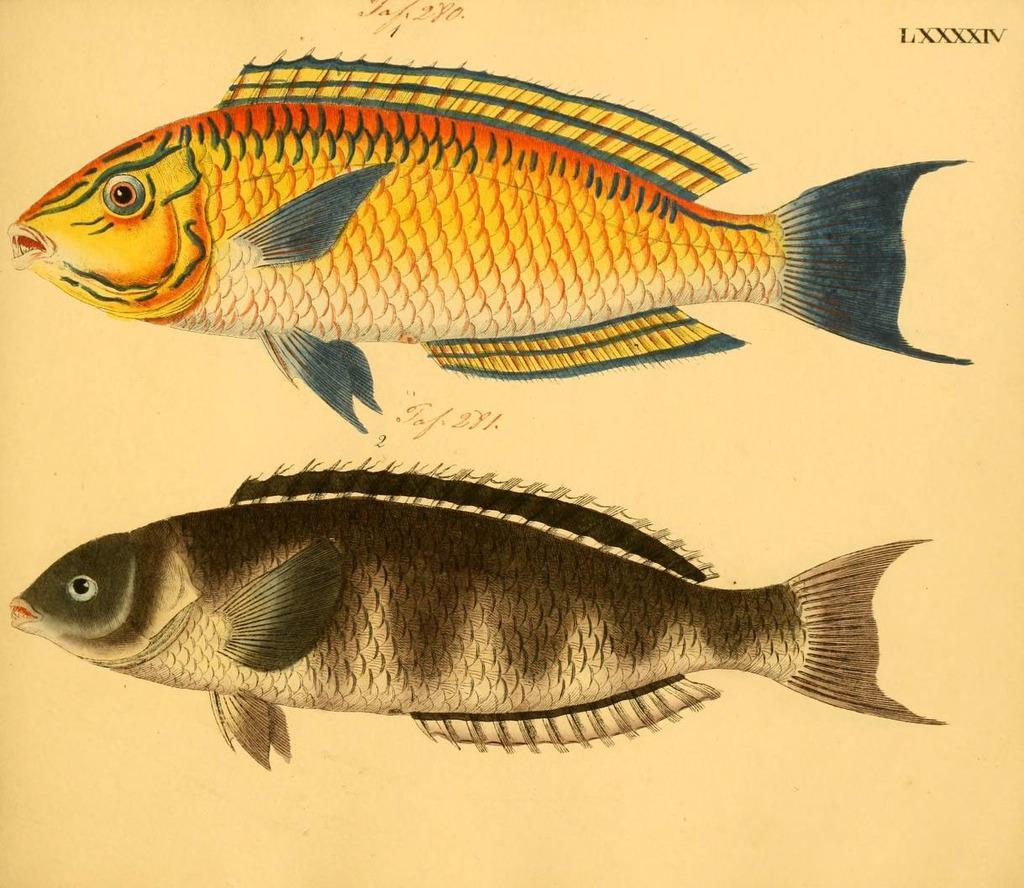How would you summarize this image in a sentence or two? In the image there are two fishes. To the top of the image there is a fish with orange, white and grey color. And below that fish there is another fish with white and grey color. To the right top corner of the image there is a number in roman letters. 